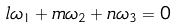Convert formula to latex. <formula><loc_0><loc_0><loc_500><loc_500>l \omega _ { 1 } + m \omega _ { 2 } + n \omega _ { 3 } = 0</formula> 